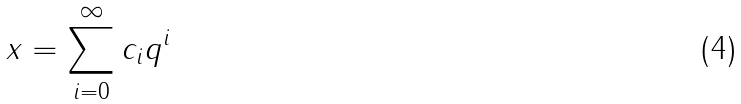Convert formula to latex. <formula><loc_0><loc_0><loc_500><loc_500>x = \sum _ { i = 0 } ^ { \infty } c _ { i } q ^ { i }</formula> 